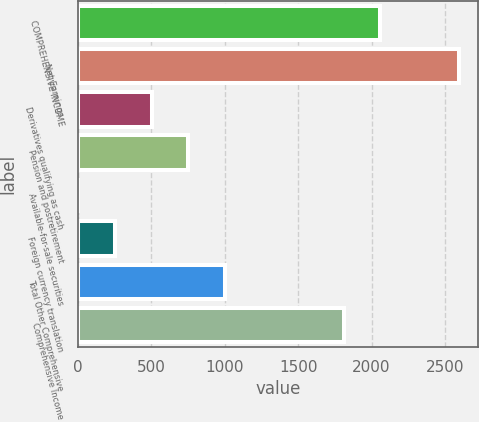Convert chart. <chart><loc_0><loc_0><loc_500><loc_500><bar_chart><fcel>COMPREHENSIVE INCOME<fcel>Net Earnings<fcel>Derivatives qualifying as cash<fcel>Pension and postretirement<fcel>Available-for-sale securities<fcel>Foreign currency translation<fcel>Total Other Comprehensive<fcel>Comprehensive Income<nl><fcel>2058.8<fcel>2593.8<fcel>502.6<fcel>752.4<fcel>3<fcel>252.8<fcel>1002.2<fcel>1809<nl></chart> 